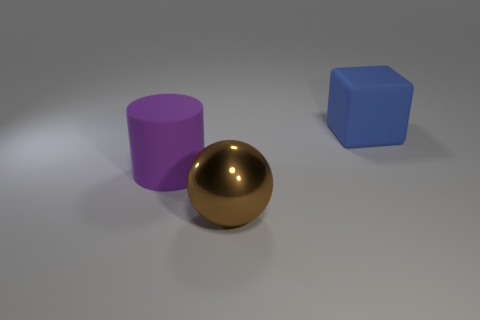Add 3 yellow matte objects. How many objects exist? 6 Subtract all cylinders. How many objects are left? 2 Subtract all large cylinders. Subtract all big brown metal spheres. How many objects are left? 1 Add 1 large purple matte things. How many large purple matte things are left? 2 Add 3 brown metal objects. How many brown metal objects exist? 4 Subtract 0 blue spheres. How many objects are left? 3 